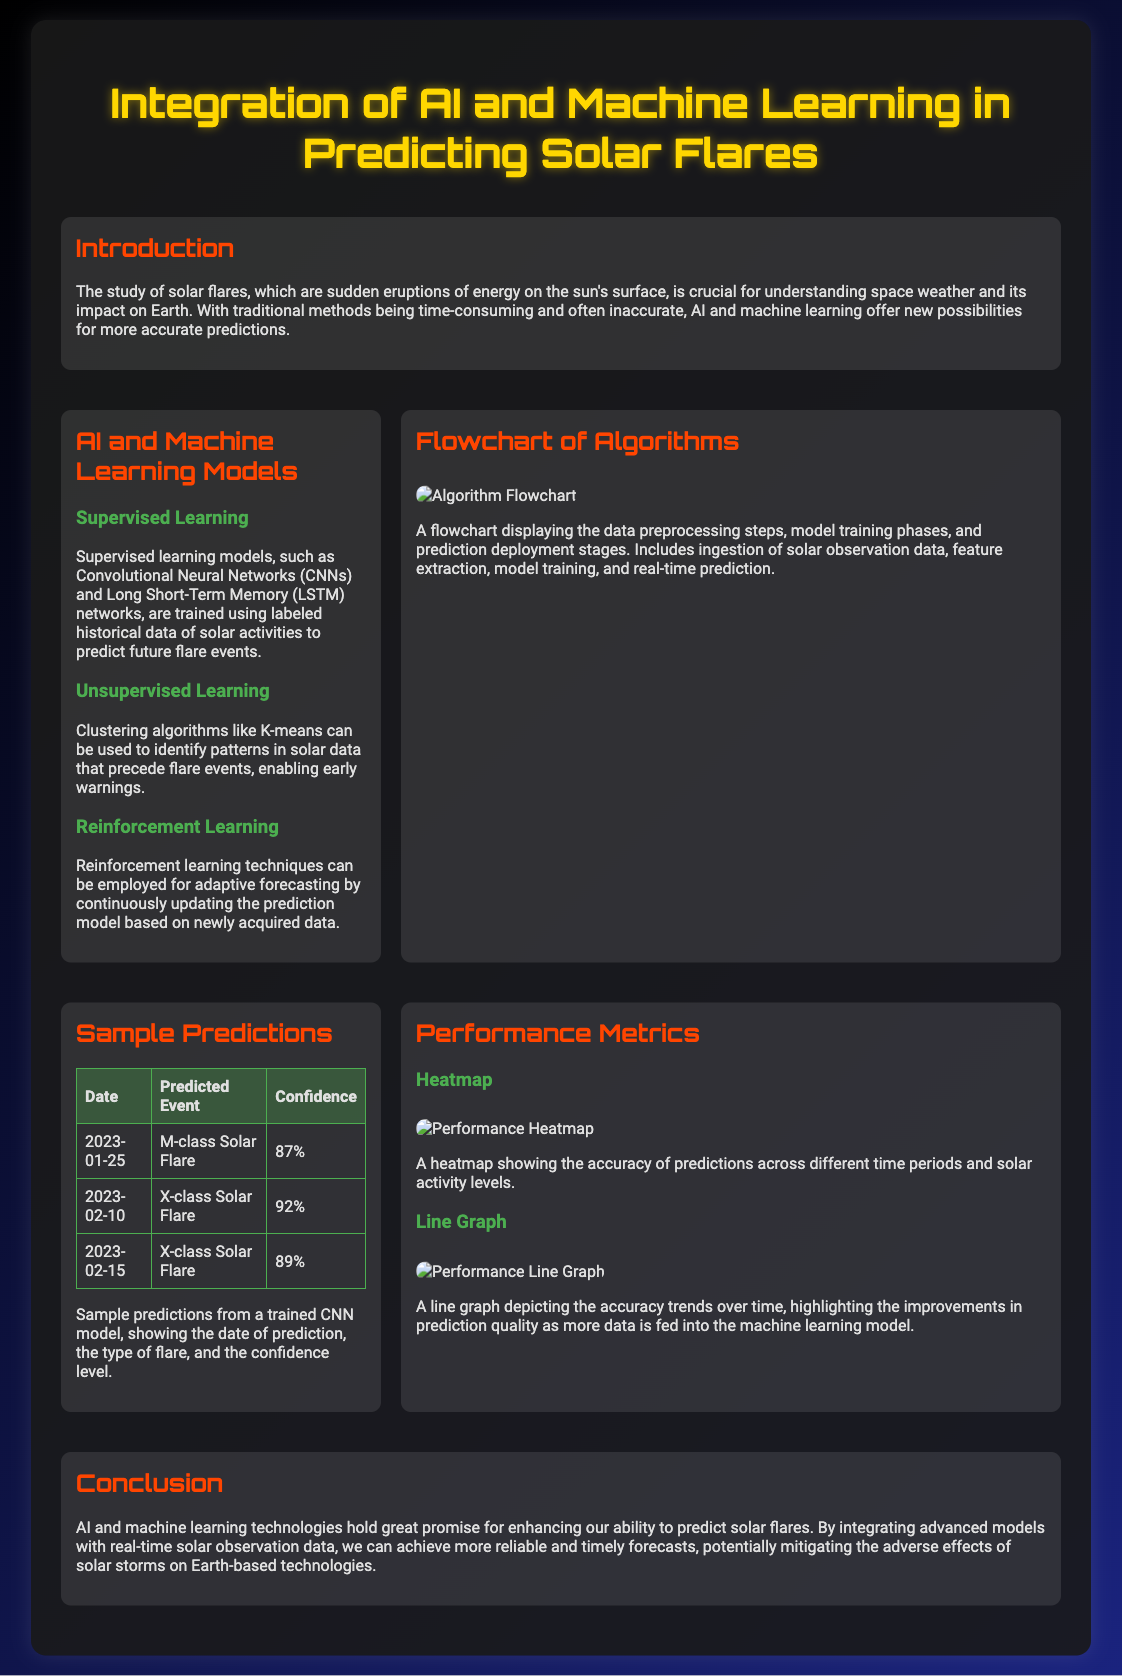What is the main topic of the poster? The poster explores the integration of AI and machine learning in predicting solar flares, providing insights into their role in forecasting solar activities.
Answer: Integration of AI and Machine Learning in Predicting Solar Flares What type of machine learning models are mentioned? The poster describes various machine learning models used for predictions, specifically supervised, unsupervised, and reinforcement learning models.
Answer: Supervised, Unsupervised, Reinforcement Learning What is the highest confidence level in the sample predictions? The table of sample predictions lists different confidence levels for various flare events, with the highest being 92%.
Answer: 92% What does the heatmap show? The heatmap depicted in the poster illustrates the accuracy of predictions across different time periods and solar activity levels.
Answer: Accuracy of predictions What is one type of solar flare mentioned in the sample predictions? The table provides several examples of predicted solar flares, including M-class and X-class solar flares.
Answer: M-class Solar Flare What is the main conclusion drawn in the poster? The conclusion emphasizes the promise of AI and machine learning technologies for improving solar flare prediction accuracy and reliability.
Answer: Enhancing prediction accuracy What does the flowchart illustrate? The flowchart shows the steps involved in data preprocessing, model training, and prediction deployment regarding solar flare predictions.
Answer: Data preprocessing steps and model training phases Which algorithm is specifically noted for clustering? The poster mentions a specific algorithm used for identifying patterns in solar data prior to flare events.
Answer: K-means How many sample predictions are offered in the table? The sample predictions section contains a total of three distinct flare predictions with corresponding dates and confidence levels.
Answer: Three 